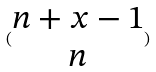Convert formula to latex. <formula><loc_0><loc_0><loc_500><loc_500>( \begin{matrix} n + x - 1 \\ n \end{matrix} )</formula> 